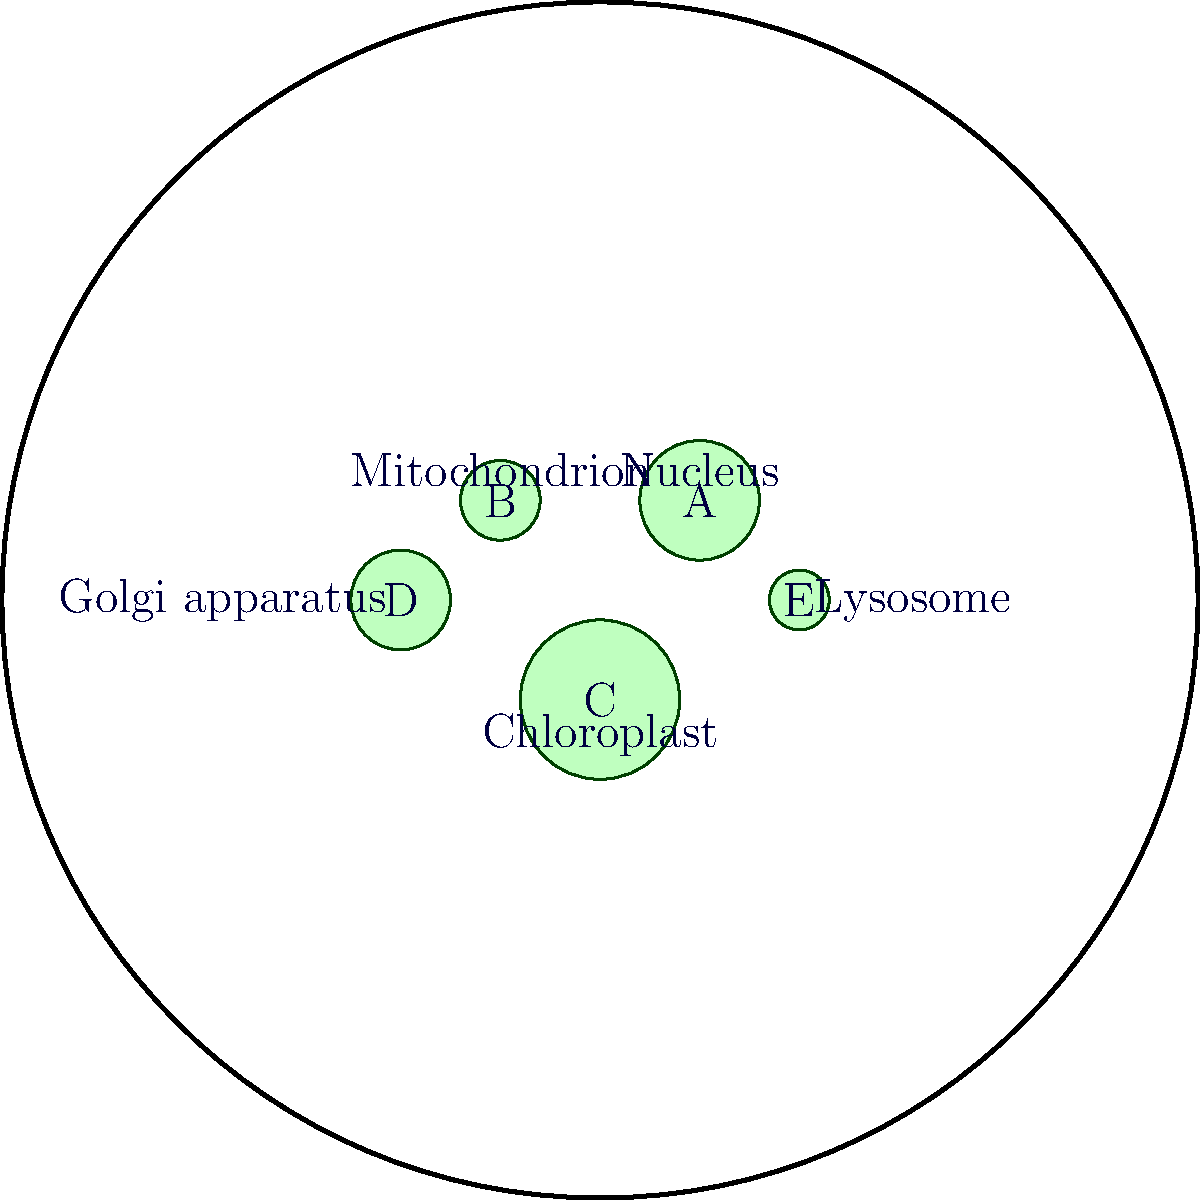In the labeled diagram of a plant cell, which organelle is responsible for photosynthesis and is marked with the letter "C"? To answer this question, we need to follow these steps:

1. Examine the labeled diagram carefully.
2. Identify the organelle marked with the letter "C".
3. Recall the functions of different cell organelles.
4. Determine which organelle is responsible for photosynthesis.

Looking at the diagram:
1. We see five labeled organelles (A, B, C, D, and E).
2. The organelle marked "C" is located at the bottom of the cell.
3. This organelle is labeled as "Chloroplast".

Recalling cell biology:
4. Chloroplasts are the organelles responsible for photosynthesis in plant cells.
5. They contain chlorophyll, which captures light energy for the photosynthetic process.
6. Other organelles shown (nucleus, mitochondrion, Golgi apparatus, and lysosome) do not perform photosynthesis.

Therefore, the organelle marked "C", which is the chloroplast, is responsible for photosynthesis in this plant cell.
Answer: Chloroplast 